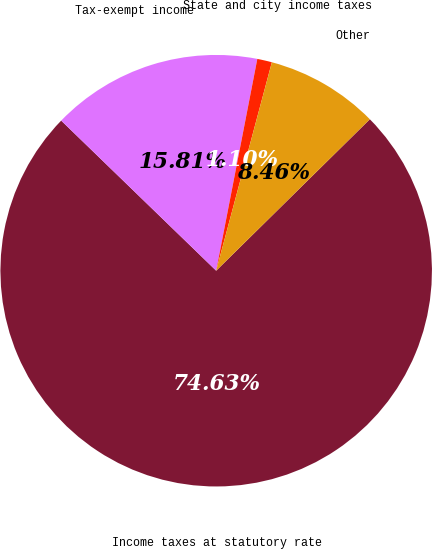<chart> <loc_0><loc_0><loc_500><loc_500><pie_chart><fcel>Income taxes at statutory rate<fcel>Tax-exempt income<fcel>State and city income taxes<fcel>Other<nl><fcel>74.63%<fcel>15.81%<fcel>1.1%<fcel>8.46%<nl></chart> 